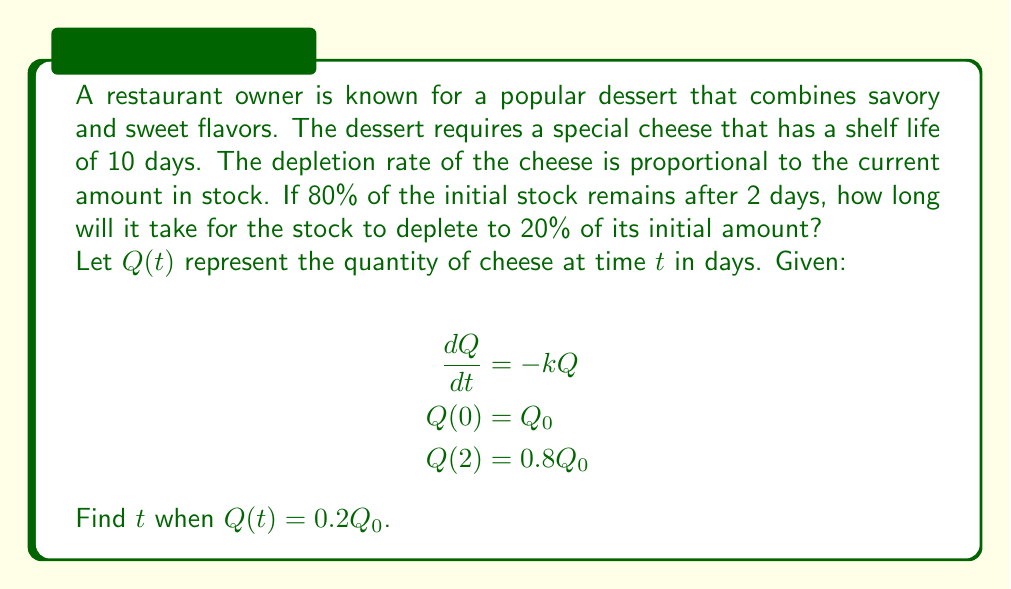Provide a solution to this math problem. Let's solve this step-by-step:

1) The general solution to the differential equation $\frac{dQ}{dt} = -kQ$ is:

   $$Q(t) = Q_0e^{-kt}$$

2) We're given that $Q(2) = 0.8Q_0$. Let's use this to find $k$:

   $$0.8Q_0 = Q_0e^{-2k}$$
   $$0.8 = e^{-2k}$$
   $$\ln(0.8) = -2k$$
   $$k = -\frac{\ln(0.8)}{2} \approx 0.1116$$

3) Now that we know $k$, we can find $t$ when $Q(t) = 0.2Q_0$:

   $$0.2Q_0 = Q_0e^{-kt}$$
   $$0.2 = e^{-kt}$$
   $$\ln(0.2) = -kt$$
   $$t = -\frac{\ln(0.2)}{k}$$

4) Substituting the value of $k$:

   $$t = -\frac{\ln(0.2)}{-\frac{\ln(0.8)}{2}}$$
   $$t = \frac{2\ln(0.2)}{\ln(0.8)}$$

5) Evaluating this expression:

   $$t \approx 7.2123$$

Therefore, it will take approximately 7.21 days for the stock to deplete to 20% of its initial amount.
Answer: $t \approx 7.21$ days 